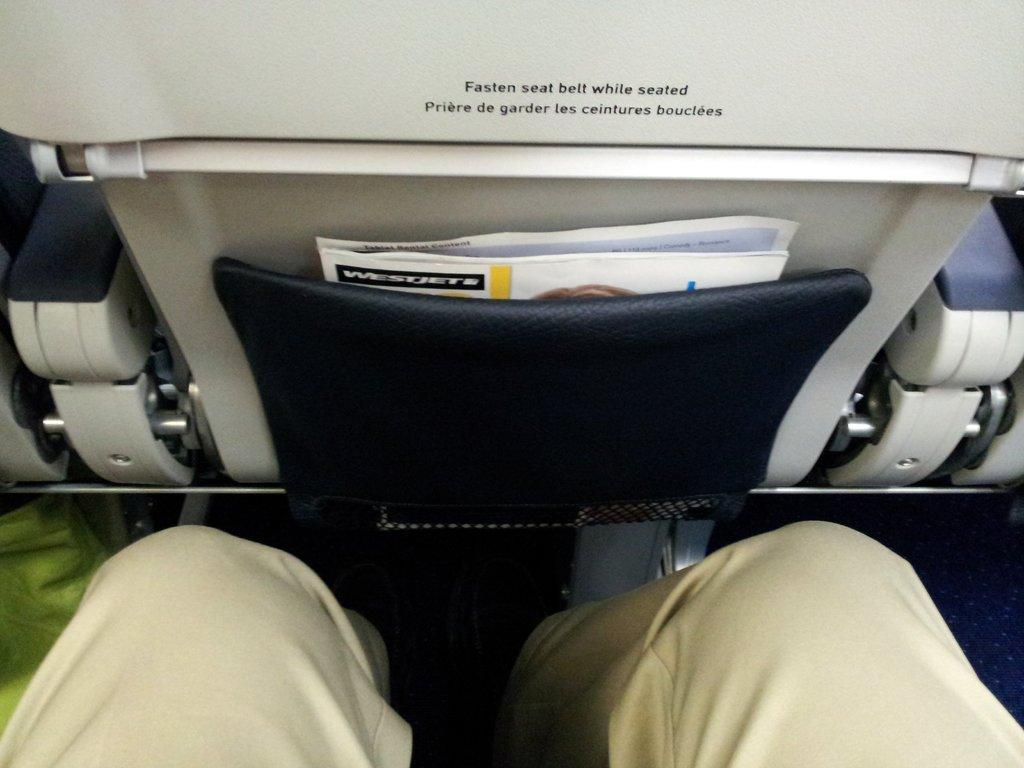What is inside the vehicle in the image? There is a person in the vehicle. What part of the person can be seen in the image? The person's legs are visible. What part of the vehicle is visible in the image? The front seat of the vehicle is visible. What objects are on the front seat? There are papers on the front seat. What is the condition of the front seat? The papers are on a seat cover. What type of education is the person pursuing in the image? There is no indication of the person's education in the image. What territory is the vehicle driving through in the image? The image does not show the vehicle driving through any specific territory. 